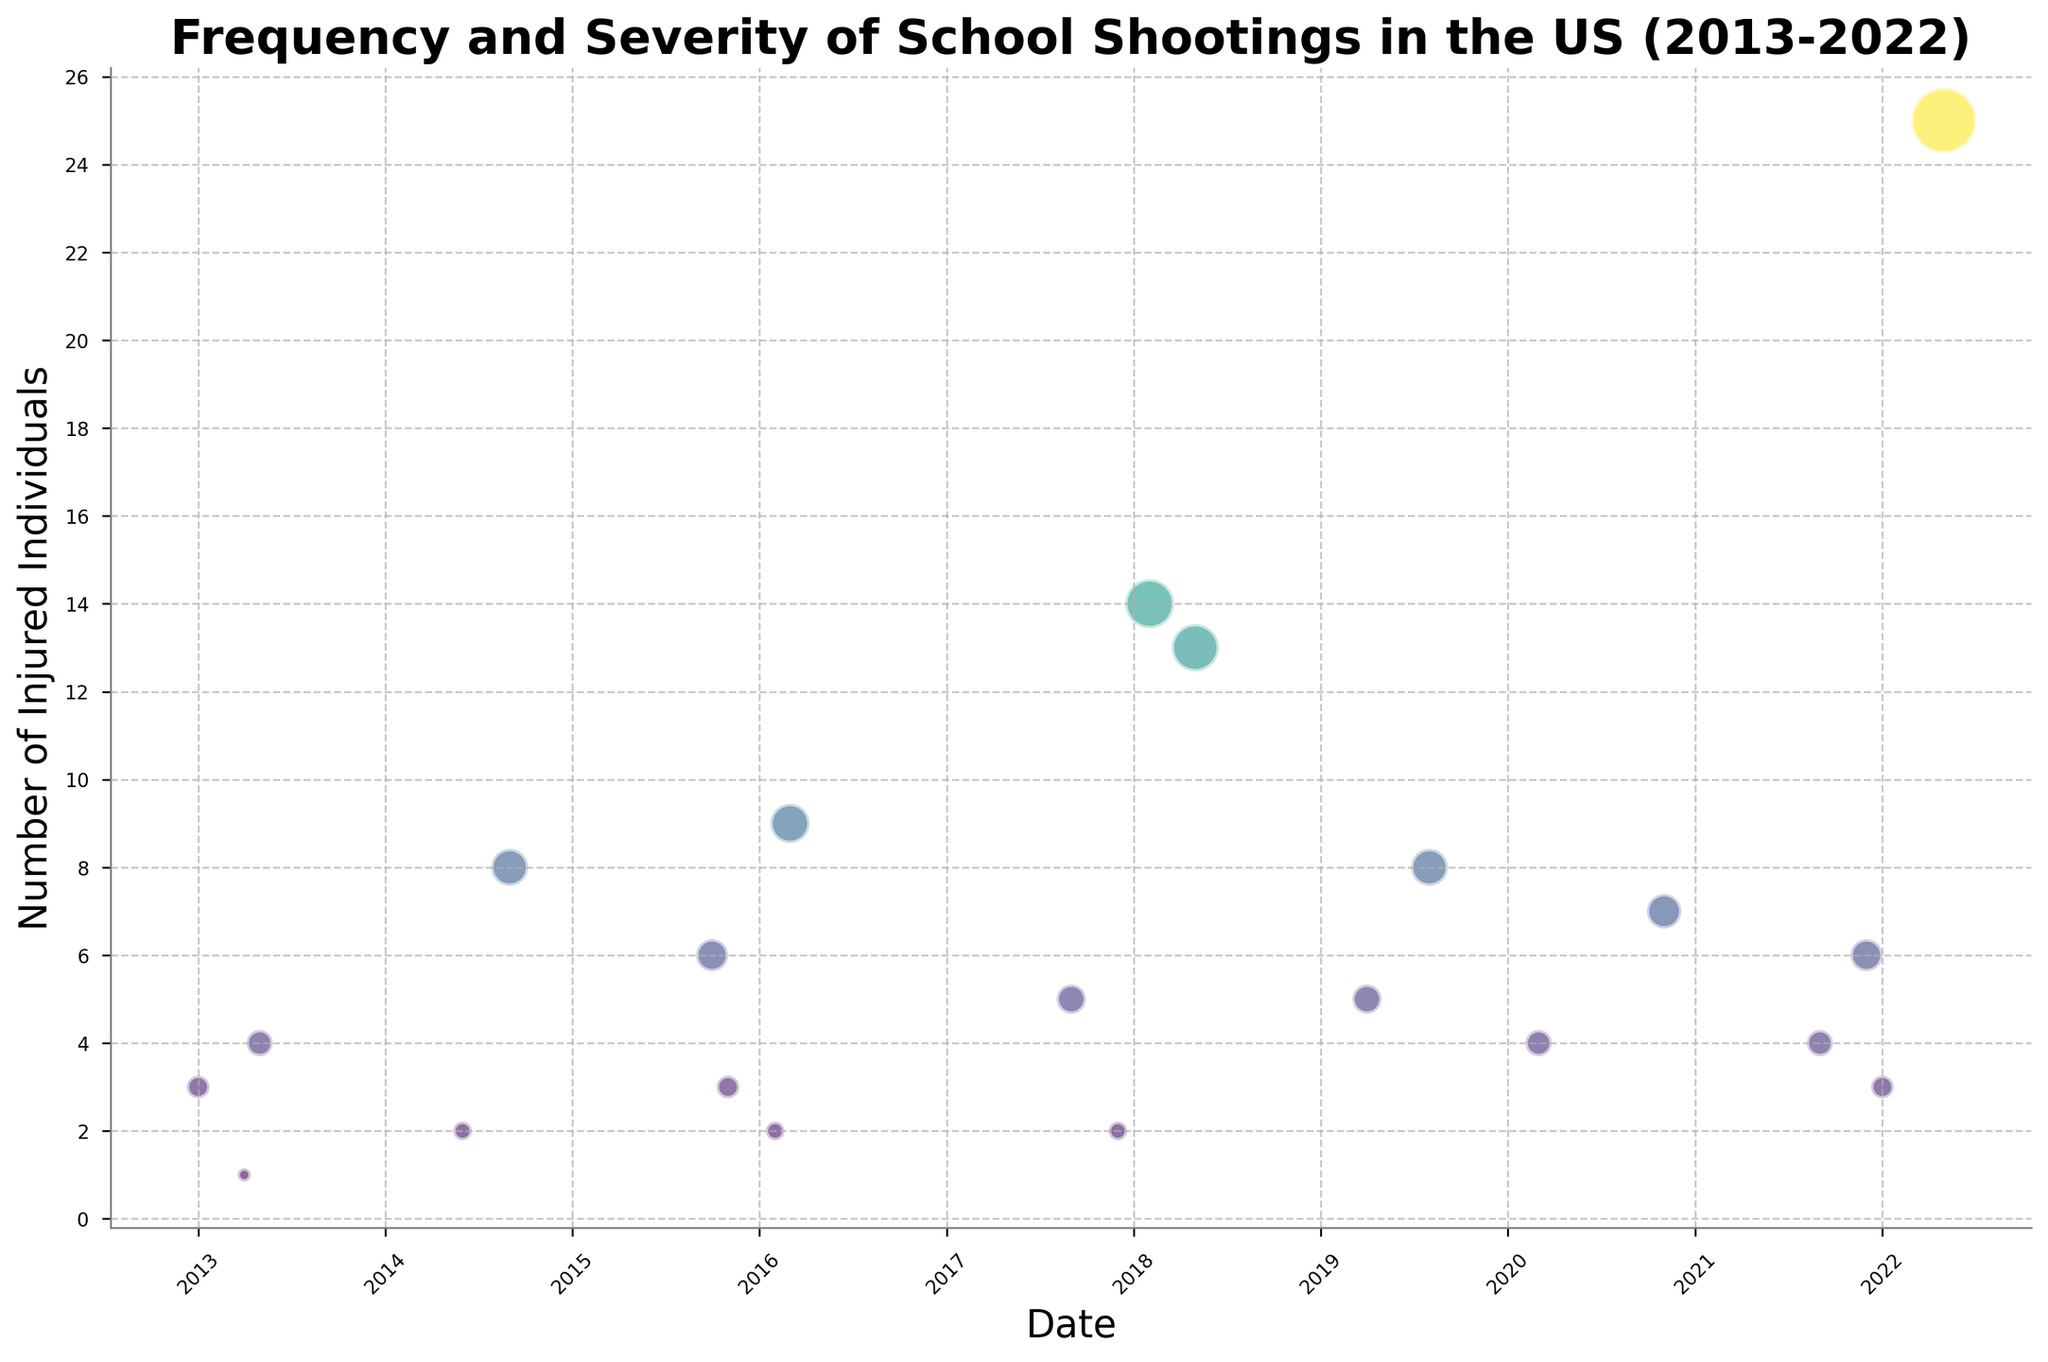What time period saw the highest number of injured individuals in a single school shooting? Look for the bubble with the largest size to identify the time period with the highest number of injured individuals. The largest bubble appears in May 2022.
Answer: May 2022 Which month had the most school shootings in the year 2018? Count the number of bubbles for each month in 2018. There are two bubbles, February and May; both occurred once.
Answer: Tie between February and May Did the number of injured individuals increase or decrease overall from 2013 to 2022? Observe the trend of bubble sizes over time from 2013 to 2022. Some years have larger bubbles, indicating an increase in injuries over time, especially in 2018 and 2022.
Answer: Increase Compare the school shootings in September between 2017 and 2021 in terms of injured individuals. Find the bubbles for September in 2017 and 2021. September 2017 had 5 injured, and September 2021 had 4 injured.
Answer: September 2017 had more injured What is the average number of injured individuals for school shootings in 2020? Identify the bubbles in 2020 and calculate their average size. The number of injuries in March is 4 and November is 7. The average is (4+7)/2 = 5.5
Answer: 5.5 Which month shows the largest variation in the number of injured individuals from 2014 to 2022? Look for the month with the most significant difference in bubble sizes. The variation is large for May, ranging from 4 injuries to 25 injuries.
Answer: May How many school shootings resulted in more than 9 injured individuals? Count the number of bubbles with sizes indicating more than 9 injured. There are 4 such bubbles (2016, 2018, 2022).
Answer: 4 Which year saw a school shooting with the same number of injured individuals as in 2015 (October)? Identify the bubble for October 2015 (6 injured) and find other bubbles with the same size. December 2021 also had 6 injured.
Answer: 2021 Is there any noticeable trend or pattern in the frequency of school shootings over the years? Count the bubbles per year to see any trends. The number of bubbles (indicating frequency) appears relatively consistent without a clear decreasing or increasing trend.
Answer: No clear trend 